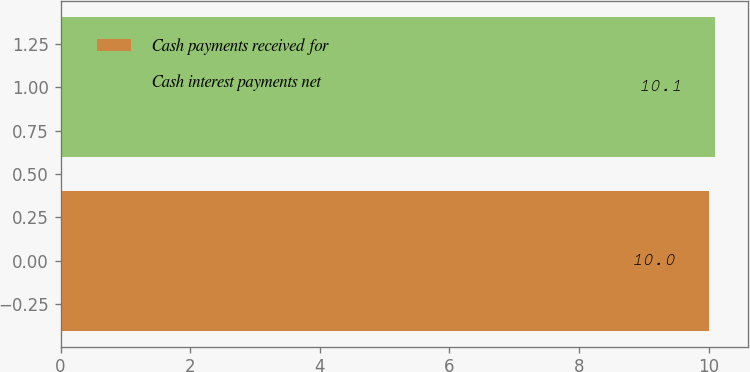Convert chart to OTSL. <chart><loc_0><loc_0><loc_500><loc_500><bar_chart><fcel>Cash payments received for<fcel>Cash interest payments net<nl><fcel>10<fcel>10.1<nl></chart> 